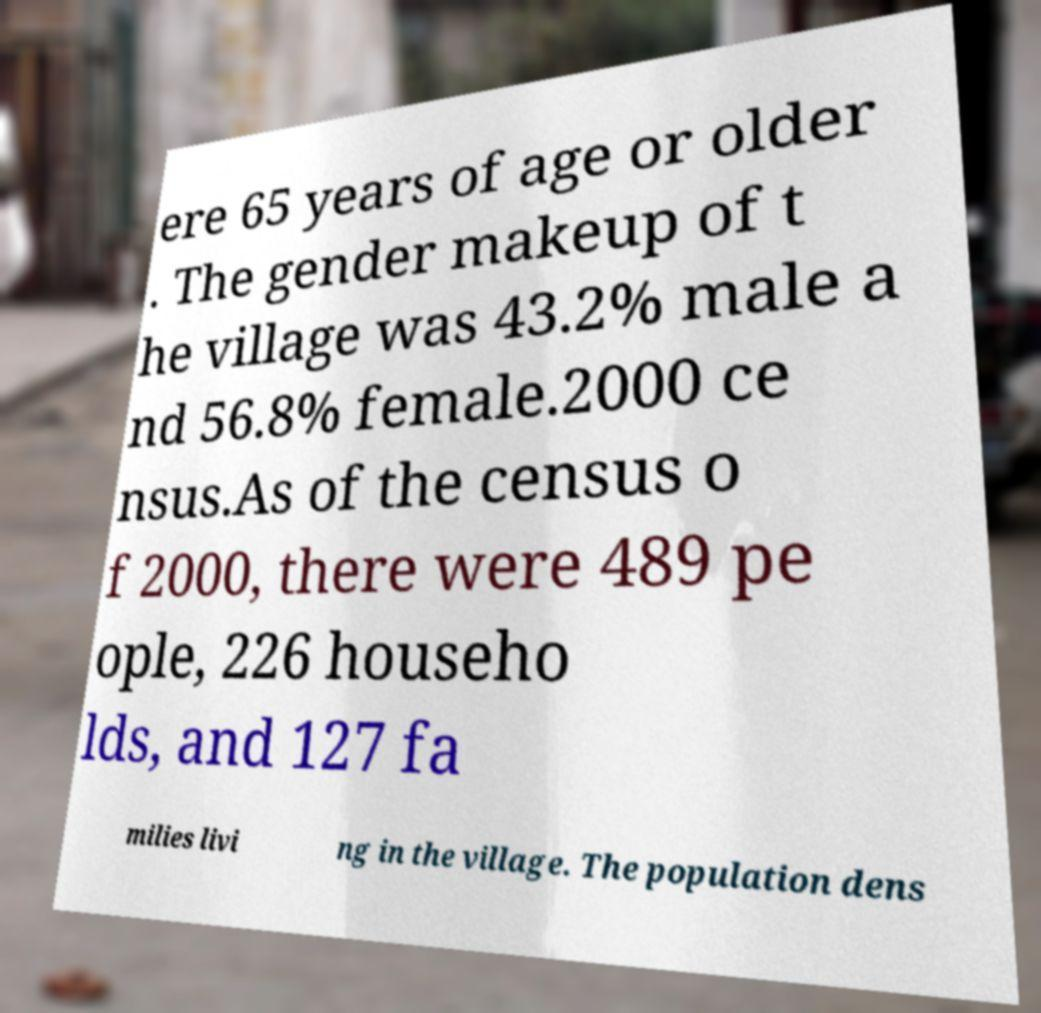Could you assist in decoding the text presented in this image and type it out clearly? ere 65 years of age or older . The gender makeup of t he village was 43.2% male a nd 56.8% female.2000 ce nsus.As of the census o f 2000, there were 489 pe ople, 226 househo lds, and 127 fa milies livi ng in the village. The population dens 